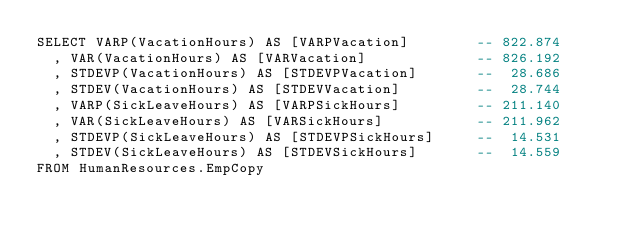Convert code to text. <code><loc_0><loc_0><loc_500><loc_500><_SQL_>SELECT VARP(VacationHours) AS [VARPVacation]        -- 822.874
  , VAR(VacationHours) AS [VARVacation]             -- 826.192
  , STDEVP(VacationHours) AS [STDEVPVacation]       --  28.686
  , STDEV(VacationHours) AS [STDEVVacation]         --  28.744
  , VARP(SickLeaveHours) AS [VARPSickHours]         -- 211.140
  , VAR(SickLeaveHours) AS [VARSickHours]           -- 211.962
  , STDEVP(SickLeaveHours) AS [STDEVPSickHours]     --  14.531
  , STDEV(SickLeaveHours) AS [STDEVSickHours]       --  14.559
FROM HumanResources.EmpCopy</code> 